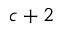Convert formula to latex. <formula><loc_0><loc_0><loc_500><loc_500>c + 2</formula> 